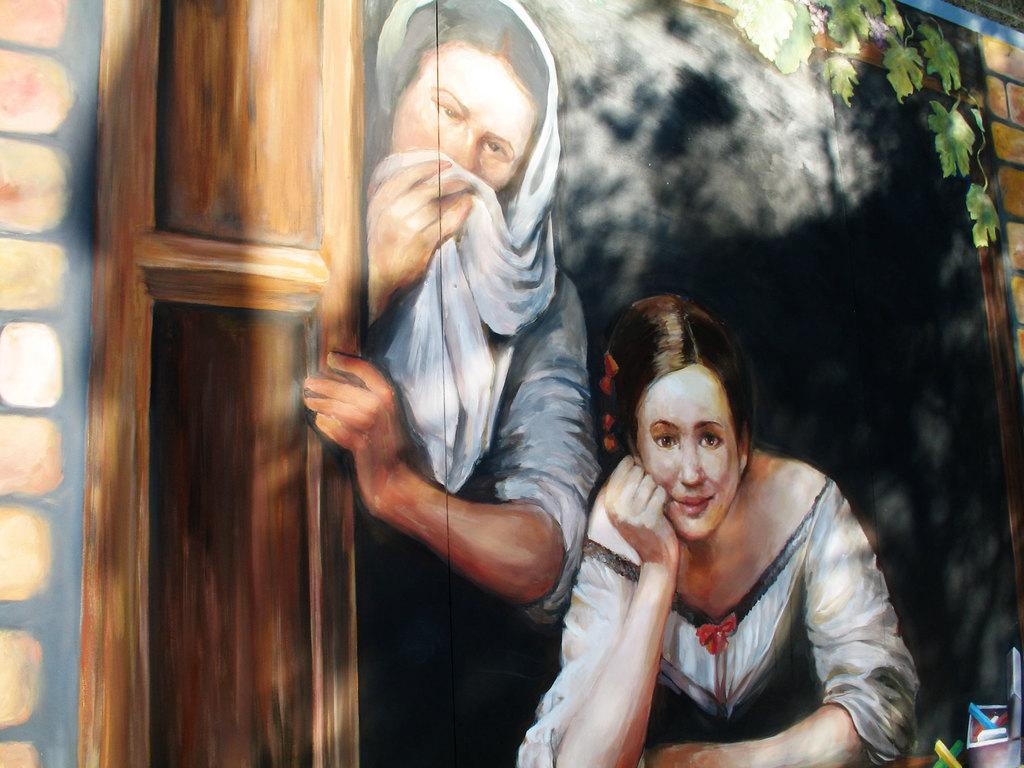What is the main subject of the image? There is a painting in the image. Where is the painting located? The painting is on a wall. Who or what is depicted in the painting? There are two women, a door, a brick wall, and a plant depicted in the painting. What type of watch is the woman wearing in the painting? There is no watch depicted on either of the women in the painting. Is there a plantation visible in the painting? No, there is no plantation depicted in the painting; only a single plant is shown. 